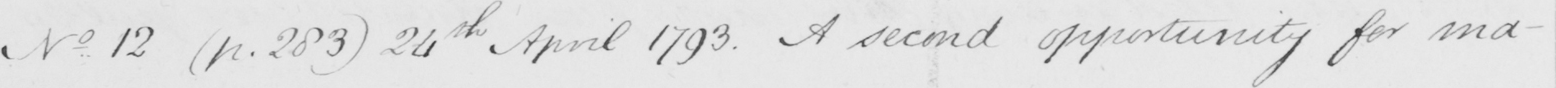Can you read and transcribe this handwriting? N . 12  ( p . 283 )  24th April 1793 . A second opportunity for ma- 